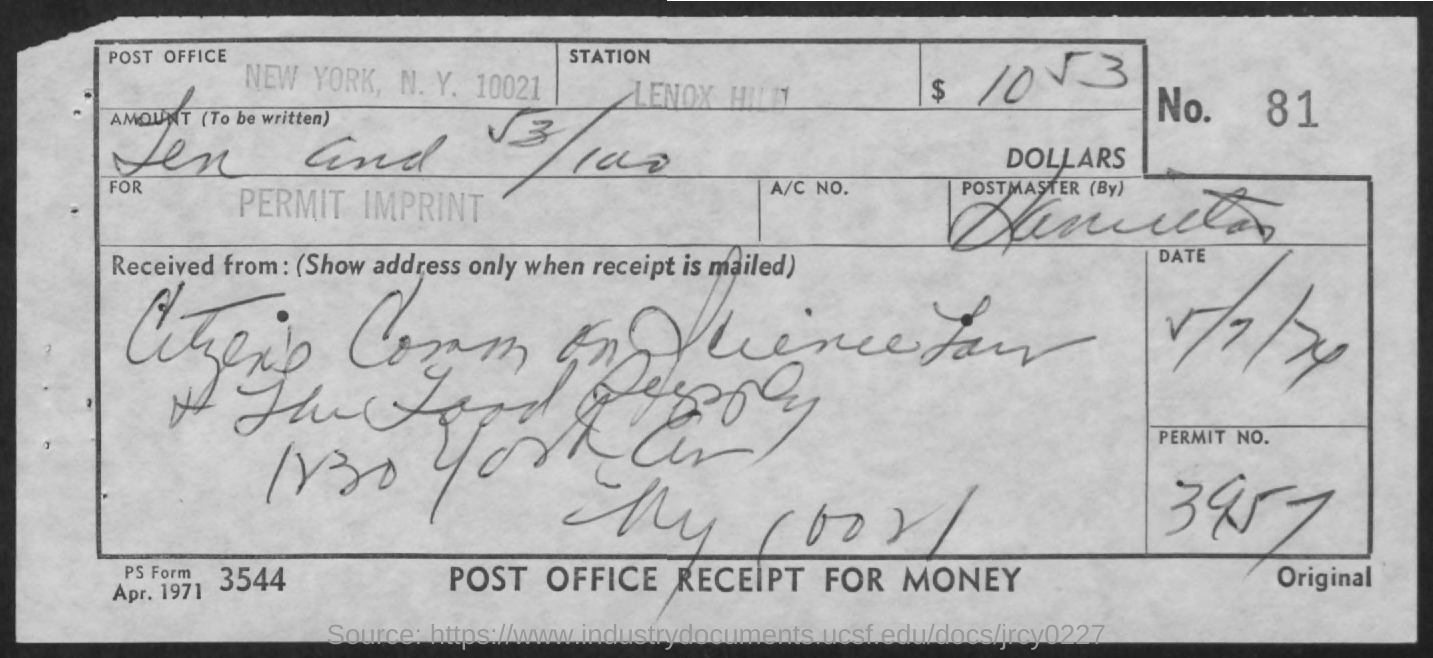What is the Permit number?
Provide a short and direct response. 3957. What is the Number?
Ensure brevity in your answer.  81. What is the Form Number?
Provide a succinct answer. 3544. 